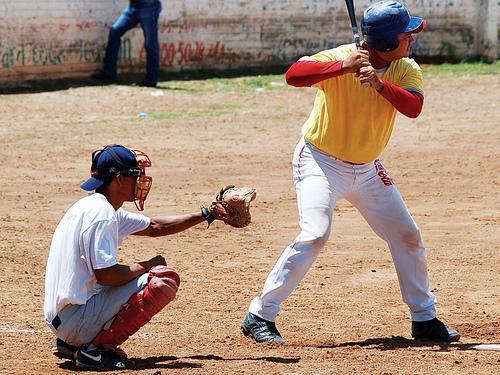How many people are there?
Give a very brief answer. 3. 